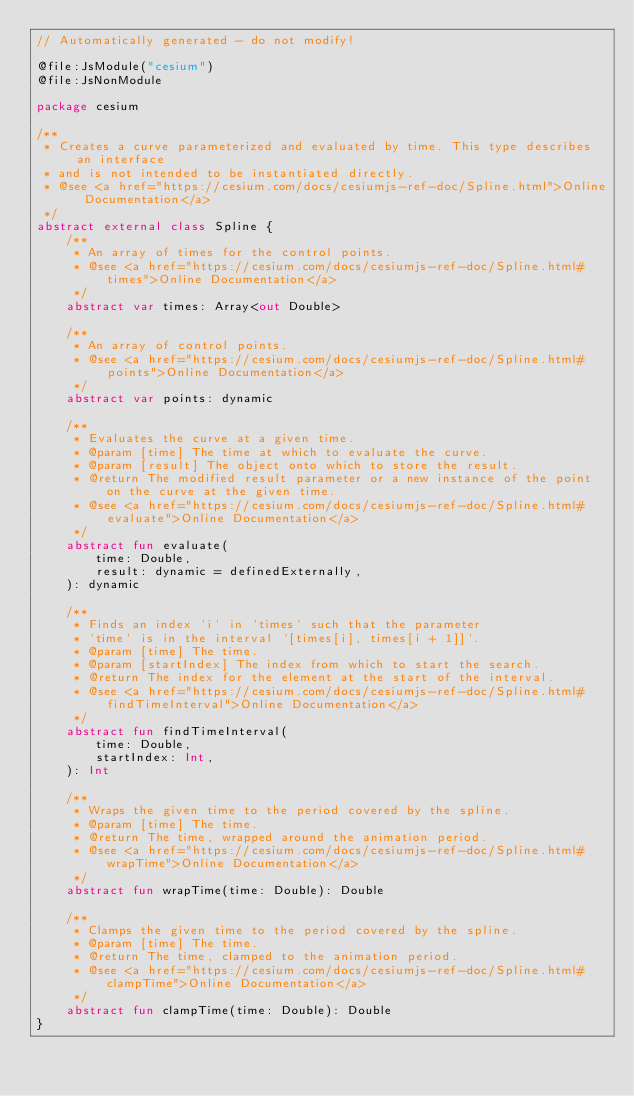Convert code to text. <code><loc_0><loc_0><loc_500><loc_500><_Kotlin_>// Automatically generated - do not modify!

@file:JsModule("cesium")
@file:JsNonModule

package cesium

/**
 * Creates a curve parameterized and evaluated by time. This type describes an interface
 * and is not intended to be instantiated directly.
 * @see <a href="https://cesium.com/docs/cesiumjs-ref-doc/Spline.html">Online Documentation</a>
 */
abstract external class Spline {
    /**
     * An array of times for the control points.
     * @see <a href="https://cesium.com/docs/cesiumjs-ref-doc/Spline.html#times">Online Documentation</a>
     */
    abstract var times: Array<out Double>

    /**
     * An array of control points.
     * @see <a href="https://cesium.com/docs/cesiumjs-ref-doc/Spline.html#points">Online Documentation</a>
     */
    abstract var points: dynamic

    /**
     * Evaluates the curve at a given time.
     * @param [time] The time at which to evaluate the curve.
     * @param [result] The object onto which to store the result.
     * @return The modified result parameter or a new instance of the point on the curve at the given time.
     * @see <a href="https://cesium.com/docs/cesiumjs-ref-doc/Spline.html#evaluate">Online Documentation</a>
     */
    abstract fun evaluate(
        time: Double,
        result: dynamic = definedExternally,
    ): dynamic

    /**
     * Finds an index `i` in `times` such that the parameter
     * `time` is in the interval `[times[i], times[i + 1]]`.
     * @param [time] The time.
     * @param [startIndex] The index from which to start the search.
     * @return The index for the element at the start of the interval.
     * @see <a href="https://cesium.com/docs/cesiumjs-ref-doc/Spline.html#findTimeInterval">Online Documentation</a>
     */
    abstract fun findTimeInterval(
        time: Double,
        startIndex: Int,
    ): Int

    /**
     * Wraps the given time to the period covered by the spline.
     * @param [time] The time.
     * @return The time, wrapped around the animation period.
     * @see <a href="https://cesium.com/docs/cesiumjs-ref-doc/Spline.html#wrapTime">Online Documentation</a>
     */
    abstract fun wrapTime(time: Double): Double

    /**
     * Clamps the given time to the period covered by the spline.
     * @param [time] The time.
     * @return The time, clamped to the animation period.
     * @see <a href="https://cesium.com/docs/cesiumjs-ref-doc/Spline.html#clampTime">Online Documentation</a>
     */
    abstract fun clampTime(time: Double): Double
}
</code> 